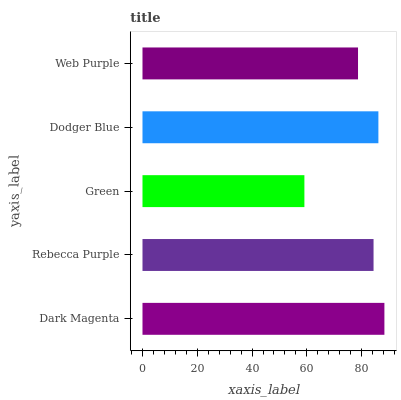Is Green the minimum?
Answer yes or no. Yes. Is Dark Magenta the maximum?
Answer yes or no. Yes. Is Rebecca Purple the minimum?
Answer yes or no. No. Is Rebecca Purple the maximum?
Answer yes or no. No. Is Dark Magenta greater than Rebecca Purple?
Answer yes or no. Yes. Is Rebecca Purple less than Dark Magenta?
Answer yes or no. Yes. Is Rebecca Purple greater than Dark Magenta?
Answer yes or no. No. Is Dark Magenta less than Rebecca Purple?
Answer yes or no. No. Is Rebecca Purple the high median?
Answer yes or no. Yes. Is Rebecca Purple the low median?
Answer yes or no. Yes. Is Dodger Blue the high median?
Answer yes or no. No. Is Web Purple the low median?
Answer yes or no. No. 